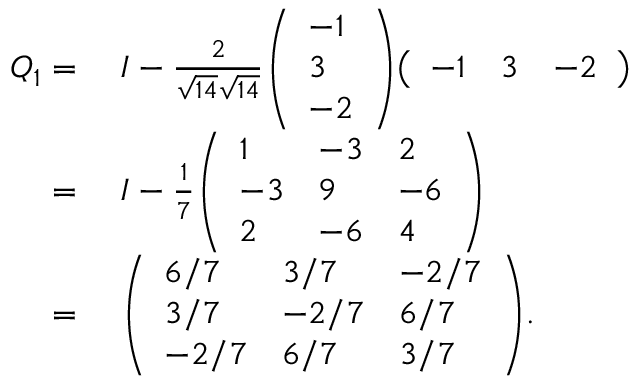<formula> <loc_0><loc_0><loc_500><loc_500>\begin{array} { r l } { Q _ { 1 } } & I - { \frac { 2 } { { \sqrt { 1 4 } } { \sqrt { 1 4 } } } } { \left ( \begin{array} { l } { - 1 } \\ { 3 } \\ { - 2 } \end{array} \right ) } { \left ( \begin{array} { l l l } { - 1 } & { 3 } & { - 2 } \end{array} \right ) } } \\ { } & I - { \frac { 1 } { 7 } } { \left ( \begin{array} { l l l } { 1 } & { - 3 } & { 2 } \\ { - 3 } & { 9 } & { - 6 } \\ { 2 } & { - 6 } & { 4 } \end{array} \right ) } } \\ { } & { \left ( \begin{array} { l l l } { 6 / 7 } & { 3 / 7 } & { - 2 / 7 } \\ { 3 / 7 } & { - 2 / 7 } & { 6 / 7 } \\ { - 2 / 7 } & { 6 / 7 } & { 3 / 7 } \end{array} \right ) } . } \end{array}</formula> 